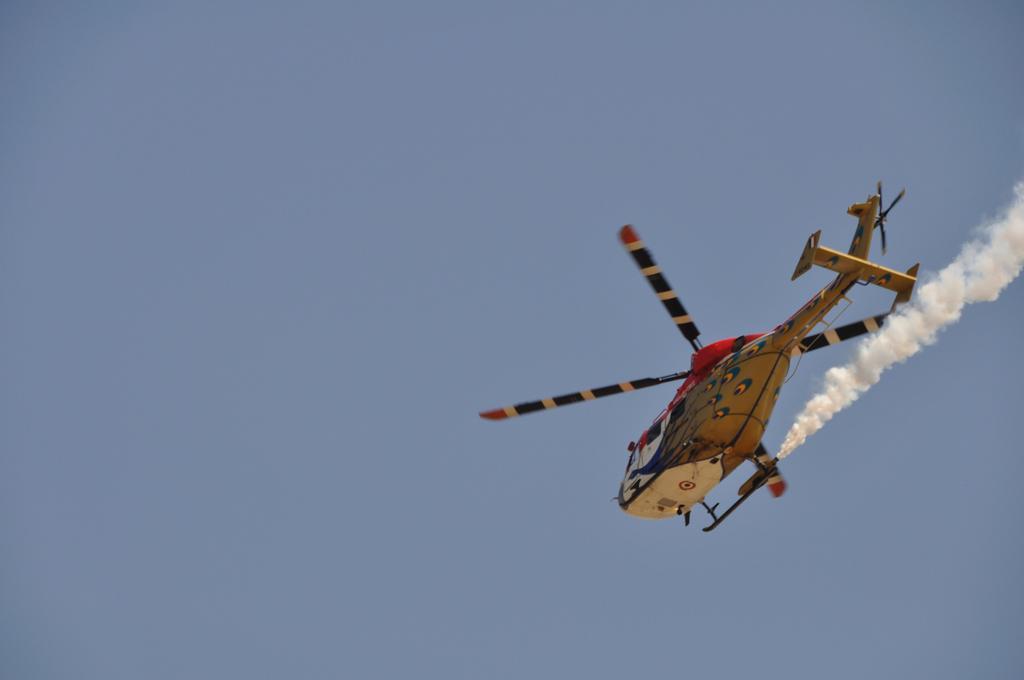Could you give a brief overview of what you see in this image? In this image we can see a helicopter flying in the sky, also we can see the smoke. 